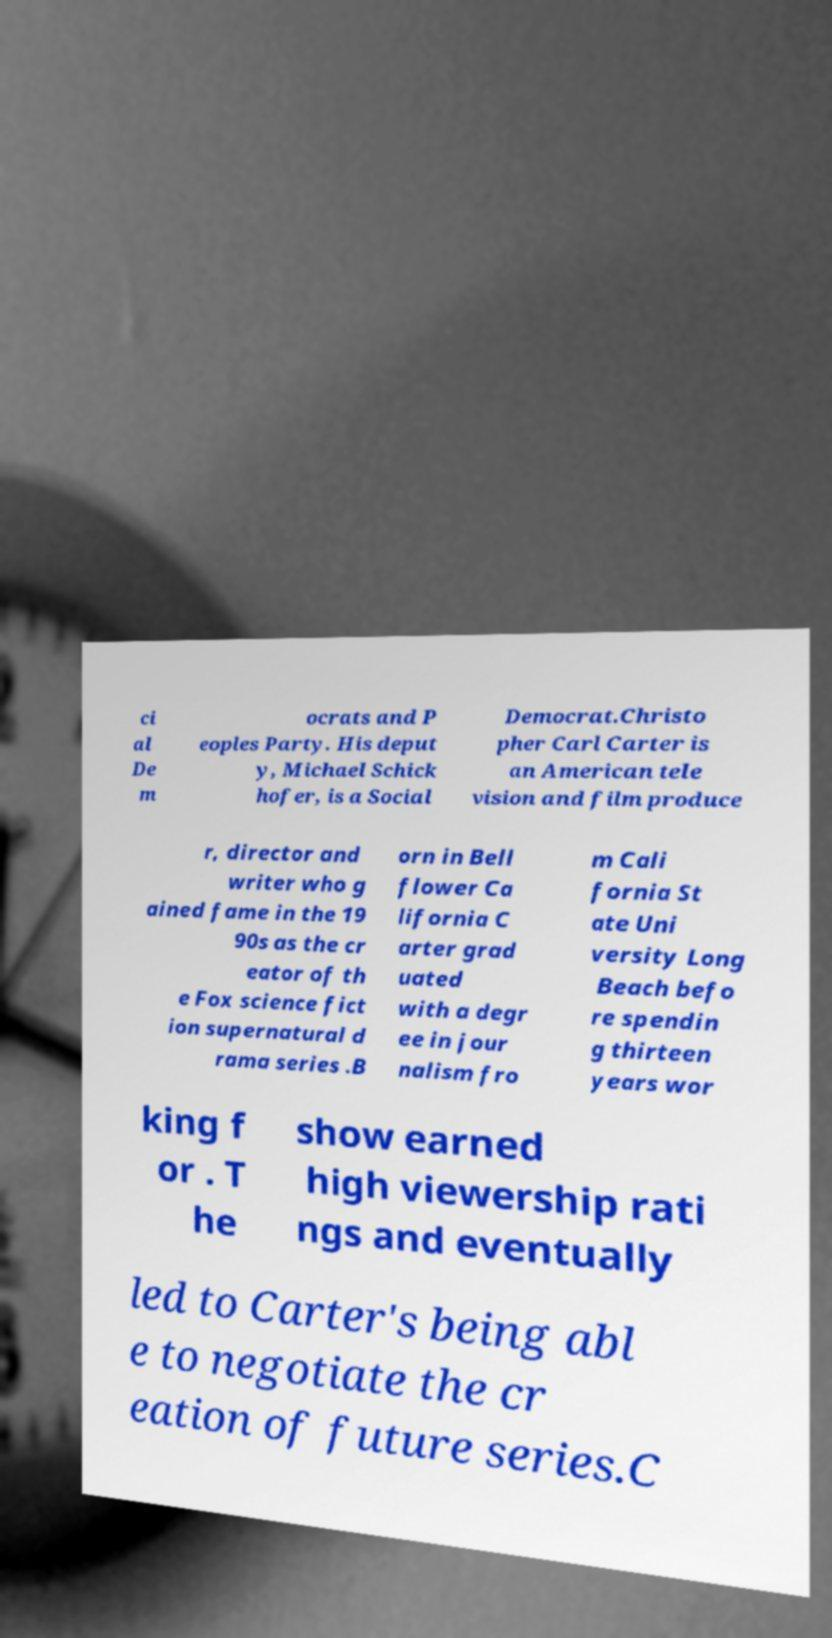Please read and relay the text visible in this image. What does it say? ci al De m ocrats and P eoples Party. His deput y, Michael Schick hofer, is a Social Democrat.Christo pher Carl Carter is an American tele vision and film produce r, director and writer who g ained fame in the 19 90s as the cr eator of th e Fox science fict ion supernatural d rama series .B orn in Bell flower Ca lifornia C arter grad uated with a degr ee in jour nalism fro m Cali fornia St ate Uni versity Long Beach befo re spendin g thirteen years wor king f or . T he show earned high viewership rati ngs and eventually led to Carter's being abl e to negotiate the cr eation of future series.C 